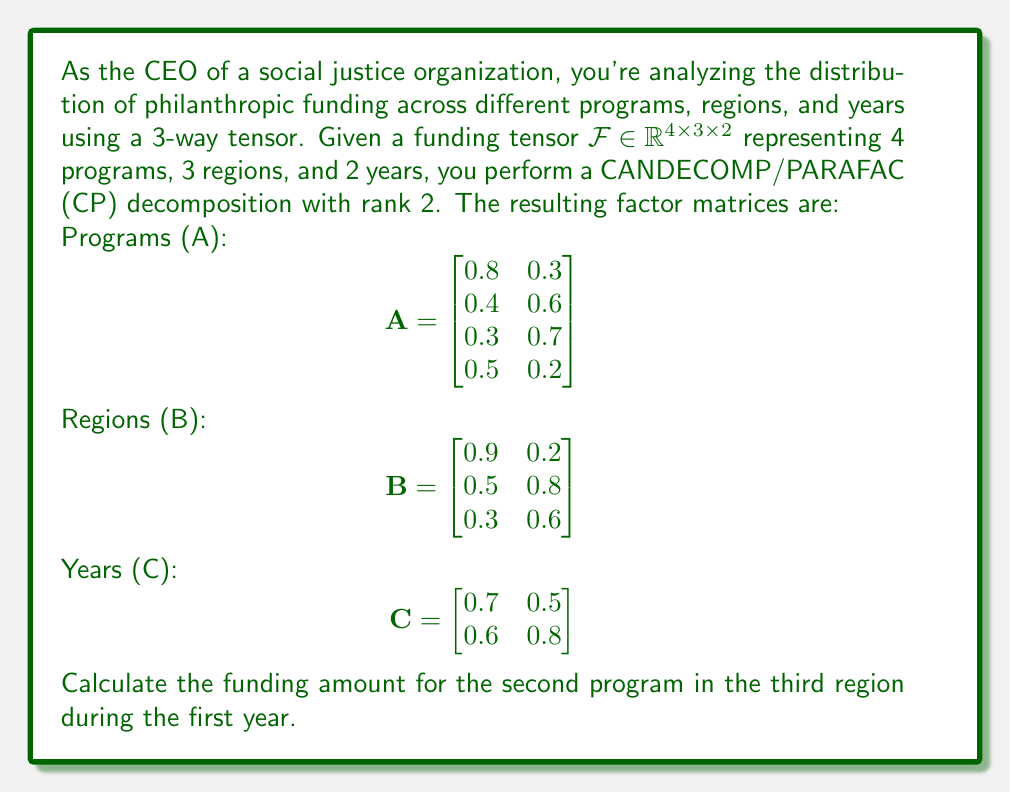Show me your answer to this math problem. To solve this problem, we'll use the CP decomposition formula and the given factor matrices. The CP decomposition approximates the tensor $\mathcal{F}$ as the sum of rank-one tensors:

$$\mathcal{F} \approx \sum_{r=1}^R a_r \circ b_r \circ c_r$$

where $R$ is the rank of the decomposition (in this case, $R=2$), and $a_r$, $b_r$, and $c_r$ are columns of the factor matrices A, B, and C respectively.

For a specific element $f_{ijk}$ of the tensor, we can calculate it as:

$$f_{ijk} \approx \sum_{r=1}^R a_{ir} b_{jr} c_{kr}$$

In our case, we need to calculate $f_{231}$, where:
- i = 2 (second program)
- j = 3 (third region)
- k = 1 (first year)

Let's substitute the values from the factor matrices:

$$f_{231} \approx (a_{21} \cdot b_{31} \cdot c_{11}) + (a_{22} \cdot b_{32} \cdot c_{12})$$

From matrix A: $a_{21} = 0.4$, $a_{22} = 0.6$
From matrix B: $b_{31} = 0.3$, $b_{32} = 0.6$
From matrix C: $c_{11} = 0.7$, $c_{12} = 0.5$

Now, let's calculate:

$$f_{231} \approx (0.4 \cdot 0.3 \cdot 0.7) + (0.6 \cdot 0.6 \cdot 0.5)$$
$$f_{231} \approx 0.084 + 0.18$$
$$f_{231} \approx 0.264$$

Therefore, the funding amount for the second program in the third region during the first year is approximately 0.264 (assuming the funding values are normalized or represented in some standard unit).
Answer: 0.264 